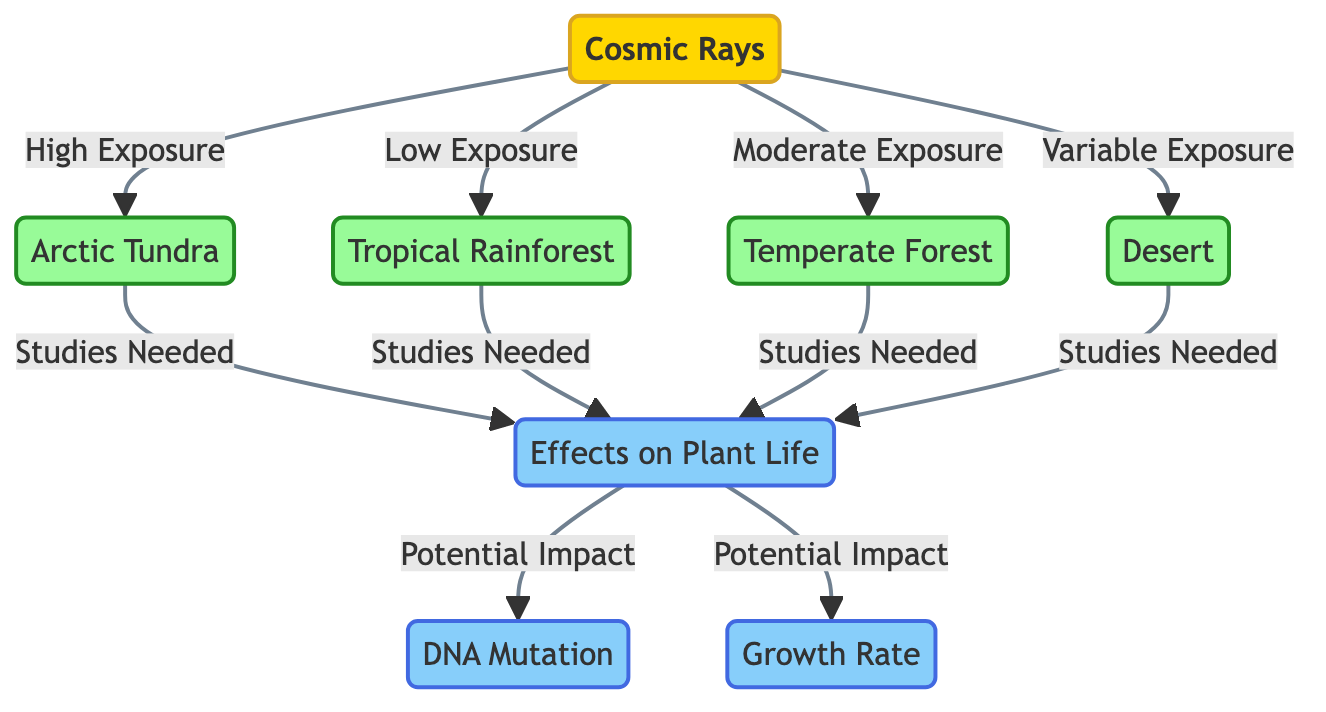What ecological zone has high exposure to cosmic rays? The diagram indicates that the Arctic Tundra is the ecological zone that receives high exposure to cosmic rays, as shown by the directed edge leading from cosmic rays to Arctic Tundra labeled "High Exposure."
Answer: Arctic Tundra What ecological zone has low exposure to cosmic rays? The diagram shows that the Tropical Rainforest has low exposure to cosmic rays, indicated by the edge from cosmic rays to Tropical Rainforest labeled "Low Exposure."
Answer: Tropical Rainforest How many types of ecological zones are represented in the diagram? There are four types of ecological zones represented: Arctic Tundra, Tropical Rainforest, Temperate Forest, and Desert. By counting the nodes labeled as zones, we find there are four.
Answer: 4 What is the potential impact of cosmic rays on plant life according to the diagram? The diagram identifies two potential impacts on plant life related to cosmic rays: DNA Mutation and Growth Rate. These are shown as connected effects from the "Effects on Plant Life" node.
Answer: DNA Mutation and Growth Rate Which ecological zone has variable exposure to cosmic rays? The diagram specifically mentions that the Desert has variable exposure to cosmic rays, denoted by the connection from cosmic rays labeled "Variable Exposure."
Answer: Desert How many ecological zones require further studies to understand the effects of cosmic rays on plants? The diagram indicates that all four ecological zones—Arctic Tundra, Tropical Rainforest, Temperate Forest, and Desert—require studies to understand the effects on plants, thus totaling four.
Answer: 4 What are the two specific effects on plants listed in this diagram? The two specific effects on plant life mentioned in the diagram are DNA Mutation and Growth Rate. These effects flow from the "Effects on Plant Life" node.
Answer: DNA Mutation and Growth Rate Which zone has moderate exposure to cosmic rays? According to the diagram, the Temperate Forest is indicated to have moderate exposure to cosmic rays, as shown by the labeled connection from cosmic rays to Temperate Forest labeled "Moderate Exposure."
Answer: Temperate Forest 